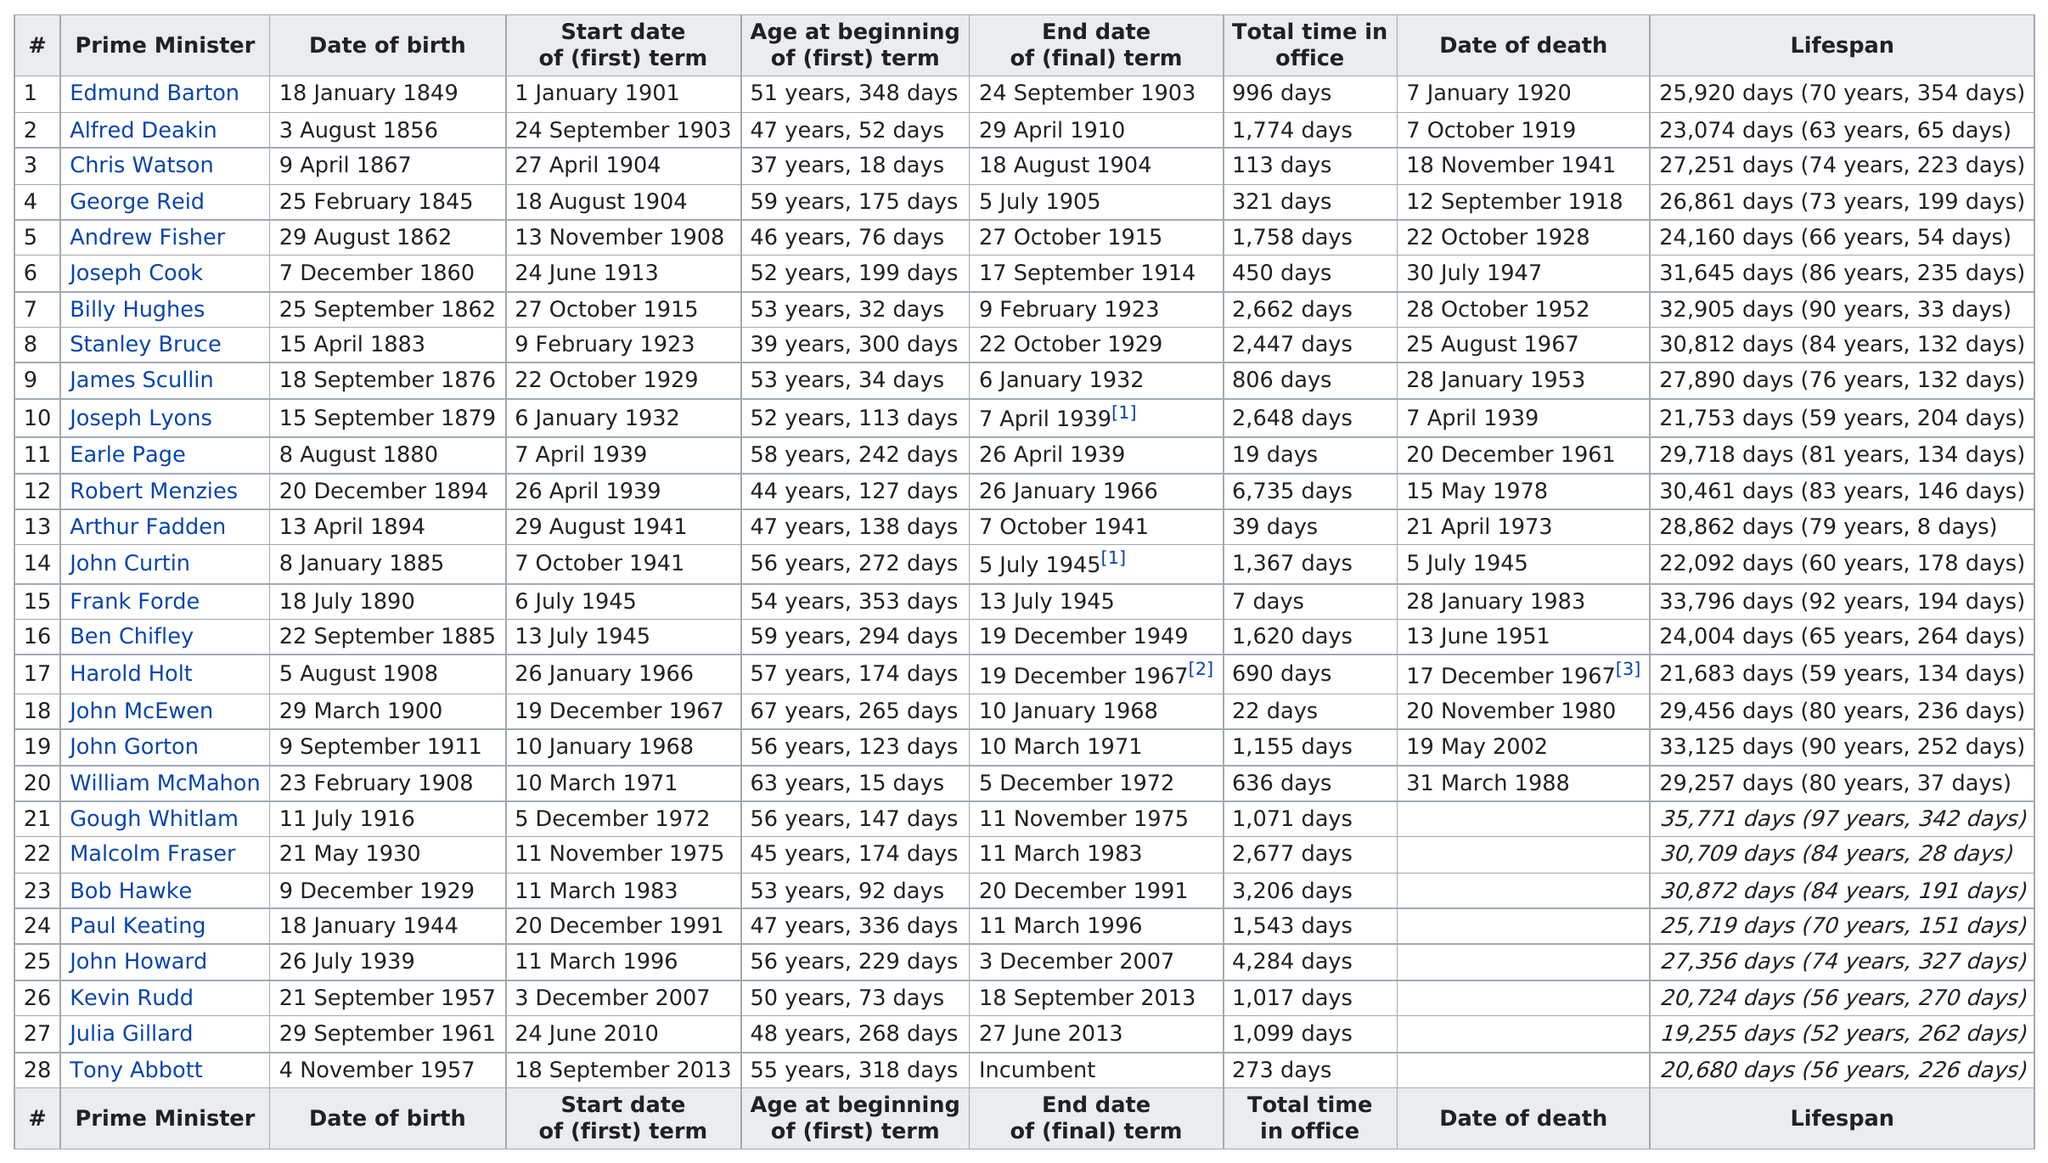Highlight a few significant elements in this photo. Joseph Lyons was in office for a period of 2,648 days. The longest serving Australian Prime Minister was John Howard, who held the office for a total of 6,735 days. Frank Forde served as the Prime Minister of Australia for the shortest total time in office among all Prime Ministers, having spent only 18 days in office. John Howard served as Prime Minister for a longer period of time than Julia Gillard. There have been two prime ministers who were born before 1850. 